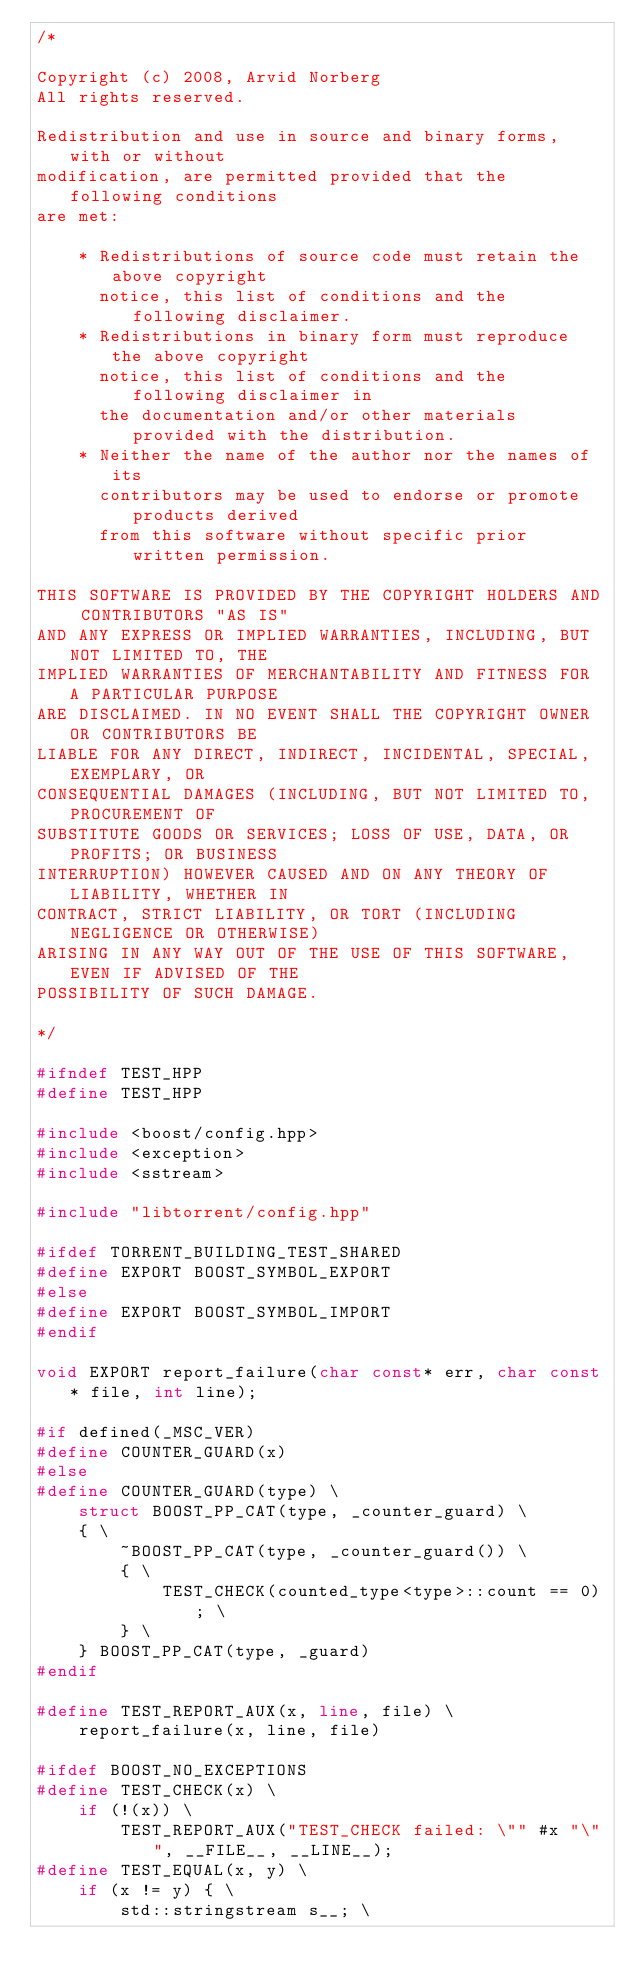<code> <loc_0><loc_0><loc_500><loc_500><_C++_>/*

Copyright (c) 2008, Arvid Norberg
All rights reserved.

Redistribution and use in source and binary forms, with or without
modification, are permitted provided that the following conditions
are met:

    * Redistributions of source code must retain the above copyright
      notice, this list of conditions and the following disclaimer.
    * Redistributions in binary form must reproduce the above copyright
      notice, this list of conditions and the following disclaimer in
      the documentation and/or other materials provided with the distribution.
    * Neither the name of the author nor the names of its
      contributors may be used to endorse or promote products derived
      from this software without specific prior written permission.

THIS SOFTWARE IS PROVIDED BY THE COPYRIGHT HOLDERS AND CONTRIBUTORS "AS IS"
AND ANY EXPRESS OR IMPLIED WARRANTIES, INCLUDING, BUT NOT LIMITED TO, THE
IMPLIED WARRANTIES OF MERCHANTABILITY AND FITNESS FOR A PARTICULAR PURPOSE
ARE DISCLAIMED. IN NO EVENT SHALL THE COPYRIGHT OWNER OR CONTRIBUTORS BE
LIABLE FOR ANY DIRECT, INDIRECT, INCIDENTAL, SPECIAL, EXEMPLARY, OR
CONSEQUENTIAL DAMAGES (INCLUDING, BUT NOT LIMITED TO, PROCUREMENT OF
SUBSTITUTE GOODS OR SERVICES; LOSS OF USE, DATA, OR PROFITS; OR BUSINESS
INTERRUPTION) HOWEVER CAUSED AND ON ANY THEORY OF LIABILITY, WHETHER IN
CONTRACT, STRICT LIABILITY, OR TORT (INCLUDING NEGLIGENCE OR OTHERWISE)
ARISING IN ANY WAY OUT OF THE USE OF THIS SOFTWARE, EVEN IF ADVISED OF THE
POSSIBILITY OF SUCH DAMAGE.

*/

#ifndef TEST_HPP
#define TEST_HPP

#include <boost/config.hpp>
#include <exception>
#include <sstream>

#include "libtorrent/config.hpp"

#ifdef TORRENT_BUILDING_TEST_SHARED
#define EXPORT BOOST_SYMBOL_EXPORT
#else
#define EXPORT BOOST_SYMBOL_IMPORT
#endif

void EXPORT report_failure(char const* err, char const* file, int line);

#if defined(_MSC_VER)
#define COUNTER_GUARD(x)
#else
#define COUNTER_GUARD(type) \
    struct BOOST_PP_CAT(type, _counter_guard) \
    { \
        ~BOOST_PP_CAT(type, _counter_guard()) \
        { \
            TEST_CHECK(counted_type<type>::count == 0); \
        } \
    } BOOST_PP_CAT(type, _guard)
#endif

#define TEST_REPORT_AUX(x, line, file) \
	report_failure(x, line, file)

#ifdef BOOST_NO_EXCEPTIONS
#define TEST_CHECK(x) \
	if (!(x)) \
		TEST_REPORT_AUX("TEST_CHECK failed: \"" #x "\"", __FILE__, __LINE__);
#define TEST_EQUAL(x, y) \
	if (x != y) { \
		std::stringstream s__; \</code> 